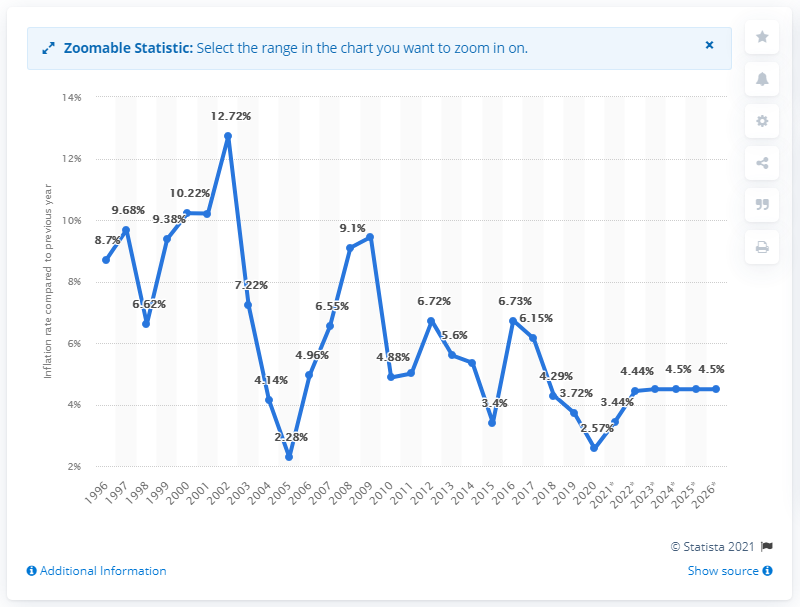List a handful of essential elements in this visual. The projected inflation rate in Namibia is expected to remain at 4.5% through 2026. Namibia's inflation reached a peak of 12.72% in 2002. 